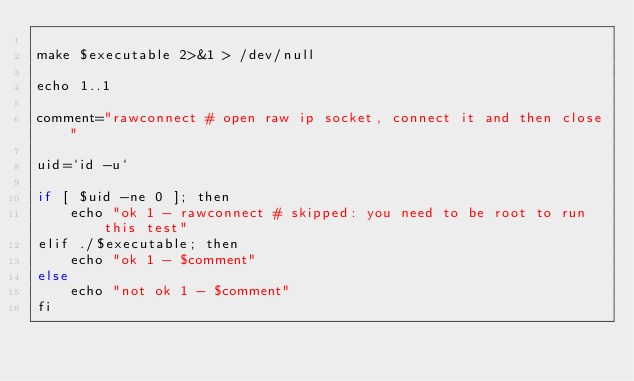Convert code to text. <code><loc_0><loc_0><loc_500><loc_500><_Perl_>
make $executable 2>&1 > /dev/null

echo 1..1

comment="rawconnect # open raw ip socket, connect it and then close"

uid=`id -u`

if [ $uid -ne 0 ]; then
	echo "ok 1 - rawconnect # skipped: you need to be root to run this test"
elif ./$executable; then
	echo "ok 1 - $comment"
else
	echo "not ok 1 - $comment"
fi
</code> 